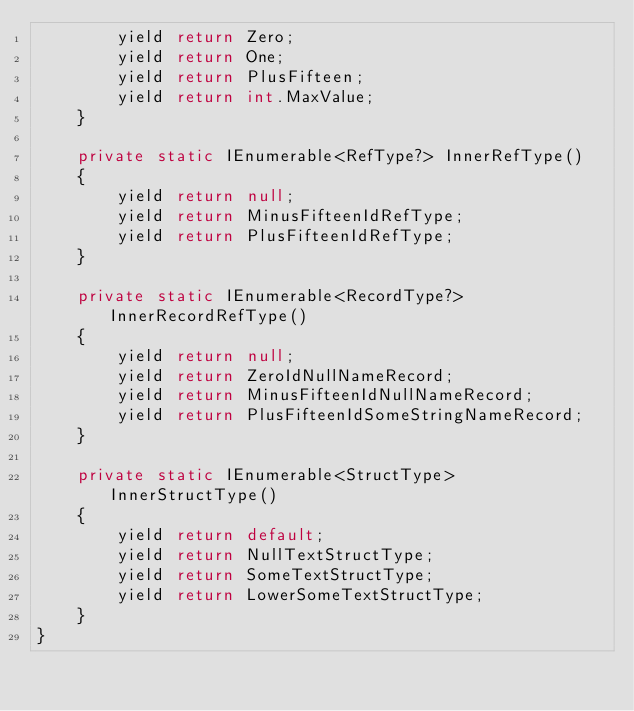Convert code to text. <code><loc_0><loc_0><loc_500><loc_500><_C#_>        yield return Zero;
        yield return One;
        yield return PlusFifteen;
        yield return int.MaxValue;
    }

    private static IEnumerable<RefType?> InnerRefType()
    {
        yield return null;
        yield return MinusFifteenIdRefType;
        yield return PlusFifteenIdRefType;
    }

    private static IEnumerable<RecordType?> InnerRecordRefType()
    {
        yield return null;
        yield return ZeroIdNullNameRecord;
        yield return MinusFifteenIdNullNameRecord;
        yield return PlusFifteenIdSomeStringNameRecord;
    }

    private static IEnumerable<StructType> InnerStructType()
    {
        yield return default;
        yield return NullTextStructType;
        yield return SomeTextStructType;
        yield return LowerSomeTextStructType;
    }
}
</code> 